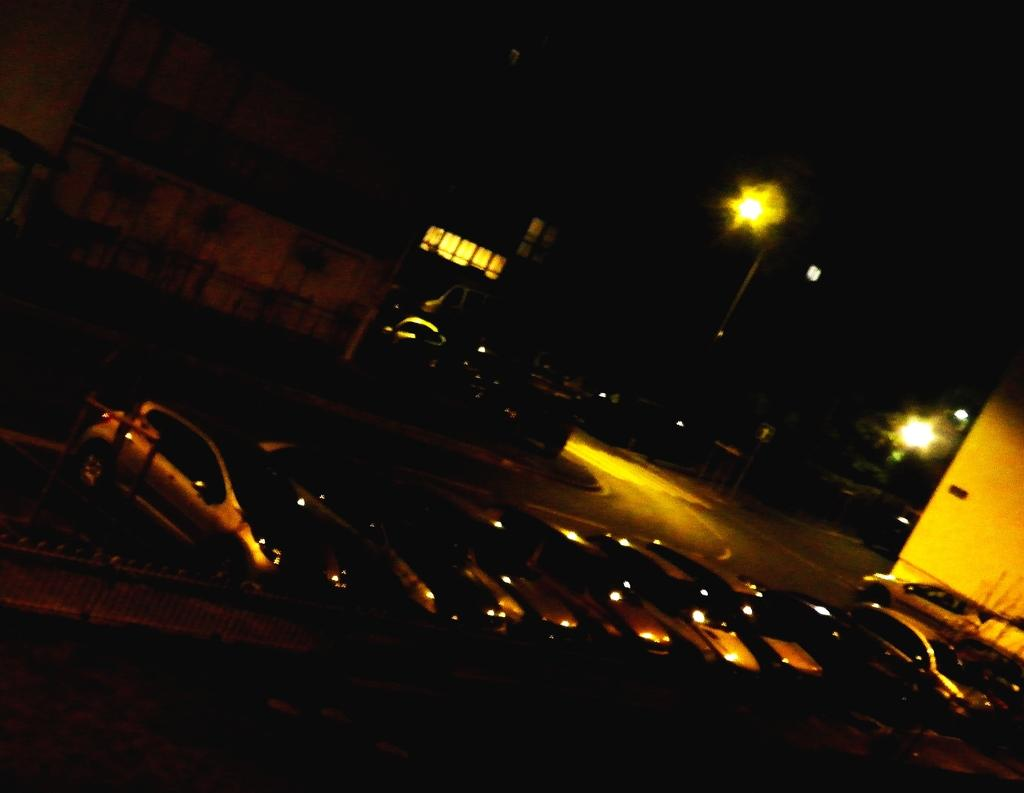What is the overall lighting condition in the image? The image is dark. What can be seen on the road in the image? There are vehicles on the road in the image. What type of structures are visible in the image? There are buildings in the image. What are the light sources in the image? There are light poles and lights in the image. Can you describe any other objects present in the image? There are other objects in the image, but their specific details are not mentioned in the provided facts. Where is the cactus located in the image? There is no cactus present in the image. What type of scissors are being used to trim the hedges in the image? There are no hedges or scissors present in the image. 